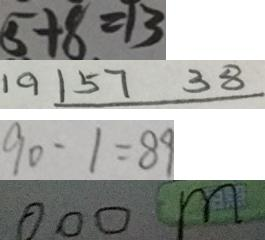Convert formula to latex. <formula><loc_0><loc_0><loc_500><loc_500>5 + 8 = 1 3 
 1 9 1 5 7 3 8 
 9 0 - 1 = 8 9 
 0 0 0 m</formula> 